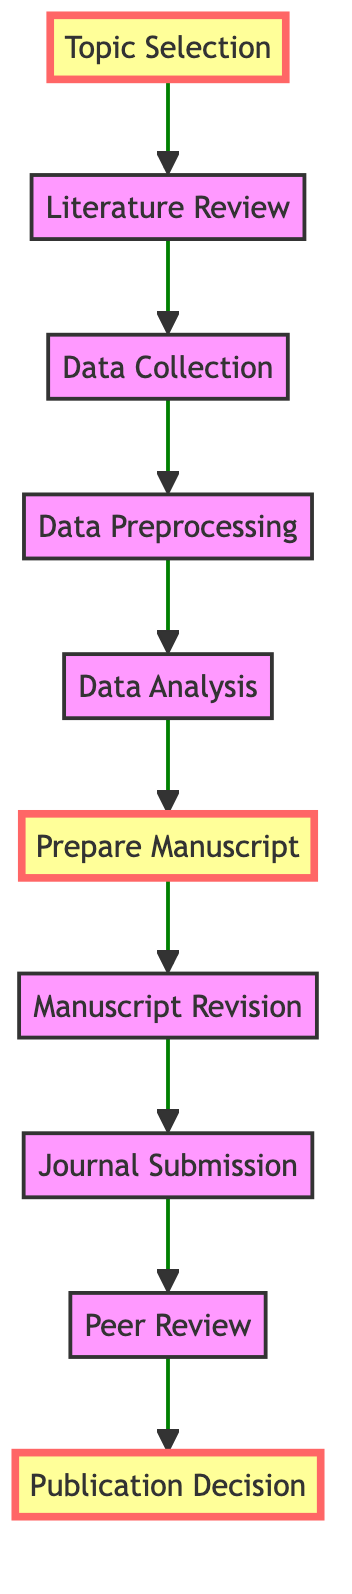What is the first step in the publication workflow? The first step in the workflow, as represented in the diagram, is "Topic Selection," which starts the sequence leading to publication.
Answer: Topic Selection What is the last step before the publication decision? In the flow of the diagram, the step right before "Publication Decision" is "Peer Review," indicating the process of review follows the submission.
Answer: Peer Review How many steps are in the publication workflow? By counting each node in the diagram, there are a total of 10 steps from "Topic Selection" to "Publication Decision."
Answer: 10 What step requires statistical analysis? The "Data Analysis" step, located after "Data Preprocessing," involves the utilization of statistical analysis tools as described in the workflow.
Answer: Data Analysis Which step is highlighted along with "Prepare Manuscript"? The step "Topic Selection" is highlighted alongside "Prepare Manuscript," indicating its significance in the process.
Answer: Topic Selection What comes after "Data Preprocessing"? Following "Data Preprocessing," the next step is "Data Analysis," demonstrating the flow and sequence necessary for preparing the data.
Answer: Data Analysis In the workflow, what happens after the "Manuscript Revision"? After the "Manuscript Revision," the next step is "Journal Submission," showing the progression from revising to submitting the manuscript.
Answer: Journal Submission Which step involves cleaning and preparing data? The "Data Preprocessing" step focuses on cleaning and preparing the collected data before analysis, as indicated in its description.
Answer: Data Preprocessing What is the nature of the connection between "Literature Review" and "Data Collection"? The connection between "Literature Review" and "Data Collection" shows a flow from one to the next, indicating that reviewing literature informs the data collection phase.
Answer: Flow (Connection) What does the "Publication Decision" entail? The "Publication Decision" encompasses receiving the final decision from the journal regarding the manuscript's status, which could vary in outcomes.
Answer: Final decision 